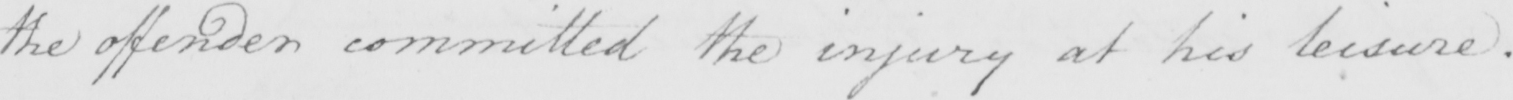Please transcribe the handwritten text in this image. the offender committed the injury at his leisure . 